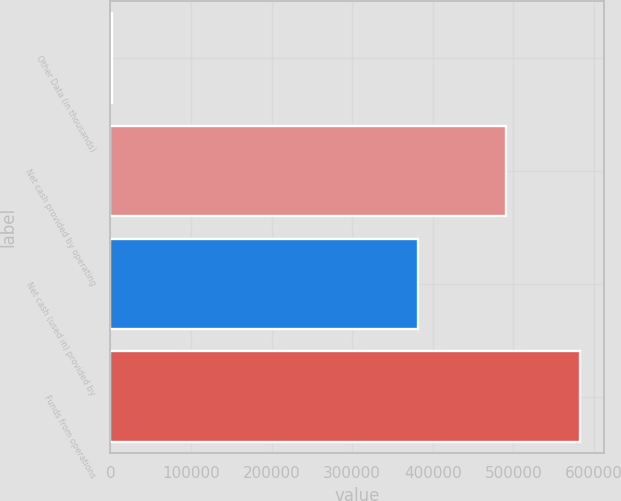Convert chart to OTSL. <chart><loc_0><loc_0><loc_500><loc_500><bar_chart><fcel>Other Data (in thousands)<fcel>Net cash provided by operating<fcel>Net cash (used in) provided by<fcel>Funds from operations<nl><fcel>2014<fcel>490381<fcel>381171<fcel>583036<nl></chart> 